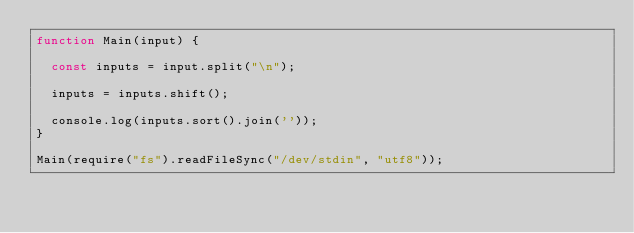<code> <loc_0><loc_0><loc_500><loc_500><_JavaScript_>function Main(input) {
  
  const inputs = input.split("\n");
  
  inputs = inputs.shift();
  
  console.log(inputs.sort().join(''));
}
 
Main(require("fs").readFileSync("/dev/stdin", "utf8"));</code> 